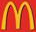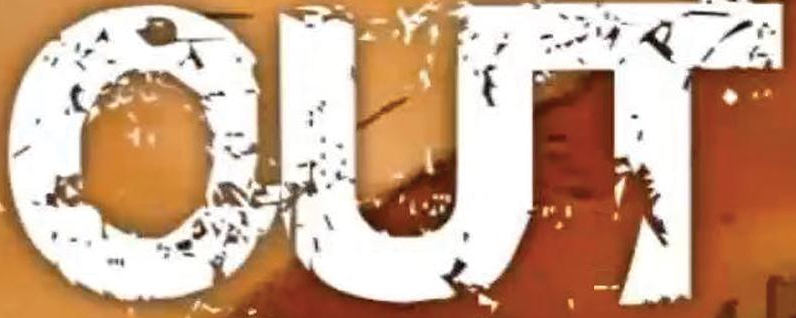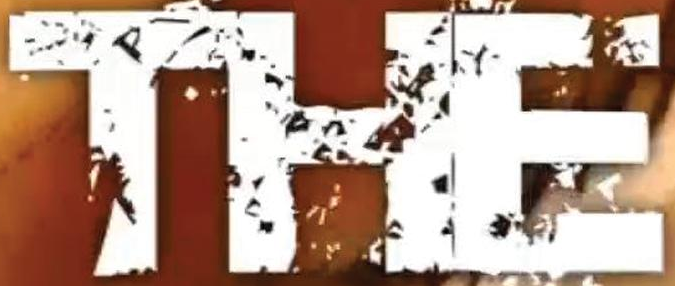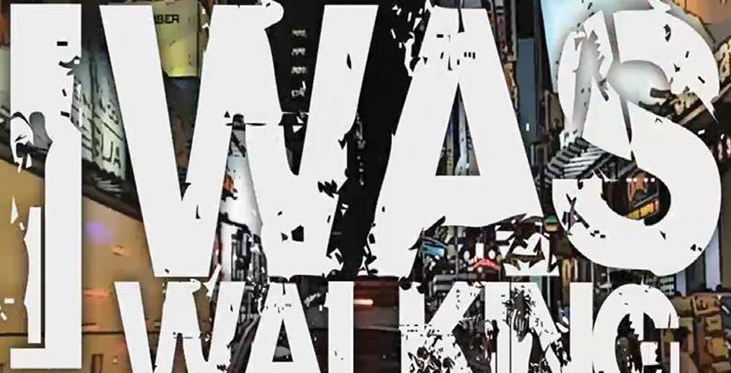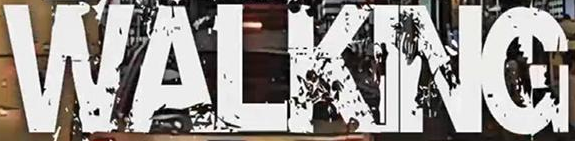What words are shown in these images in order, separated by a semicolon? m; OUT; THE; IWAS; WALKING 